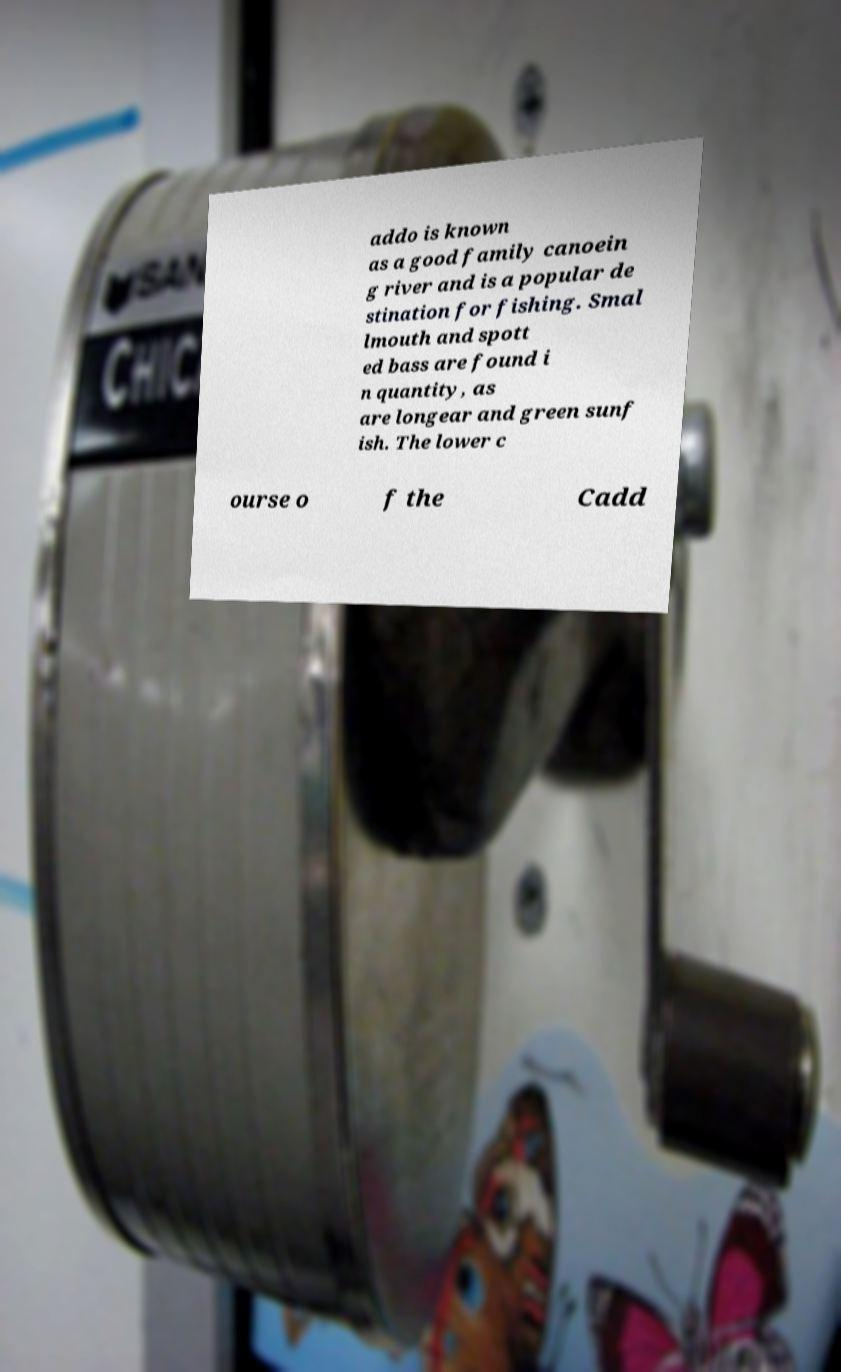Could you assist in decoding the text presented in this image and type it out clearly? addo is known as a good family canoein g river and is a popular de stination for fishing. Smal lmouth and spott ed bass are found i n quantity, as are longear and green sunf ish. The lower c ourse o f the Cadd 